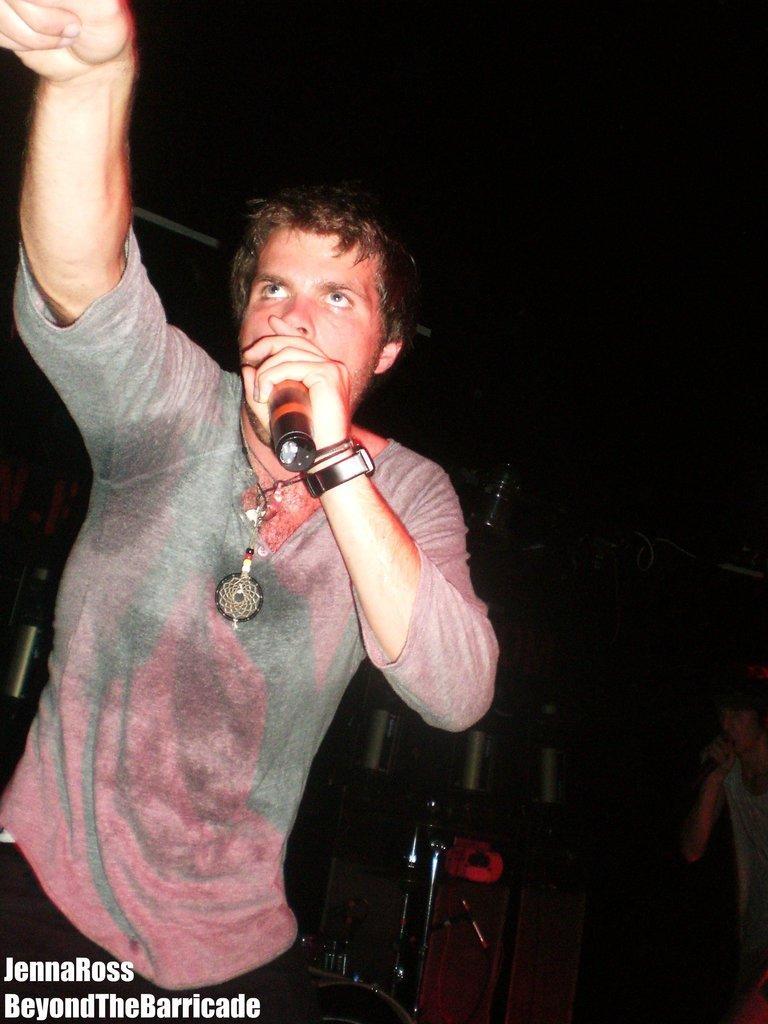Could you give a brief overview of what you see in this image? In this image I can see a person holding a mike and at the bottom I can see a text and background is dark. 